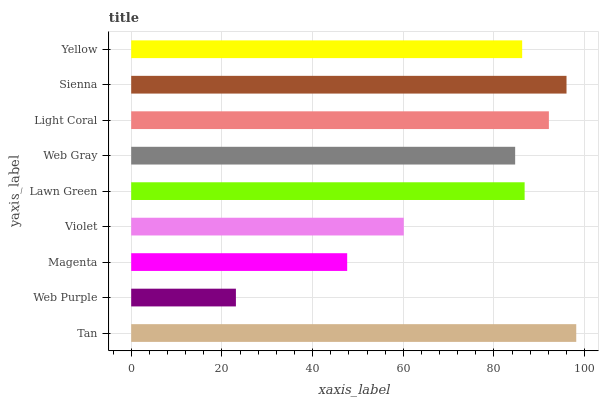Is Web Purple the minimum?
Answer yes or no. Yes. Is Tan the maximum?
Answer yes or no. Yes. Is Magenta the minimum?
Answer yes or no. No. Is Magenta the maximum?
Answer yes or no. No. Is Magenta greater than Web Purple?
Answer yes or no. Yes. Is Web Purple less than Magenta?
Answer yes or no. Yes. Is Web Purple greater than Magenta?
Answer yes or no. No. Is Magenta less than Web Purple?
Answer yes or no. No. Is Yellow the high median?
Answer yes or no. Yes. Is Yellow the low median?
Answer yes or no. Yes. Is Sienna the high median?
Answer yes or no. No. Is Sienna the low median?
Answer yes or no. No. 